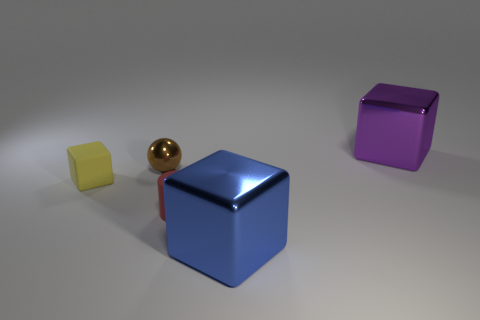Add 3 red objects. How many objects exist? 8 Subtract all cylinders. How many objects are left? 4 Subtract 1 brown balls. How many objects are left? 4 Subtract all red spheres. Subtract all red things. How many objects are left? 4 Add 5 large blue objects. How many large blue objects are left? 6 Add 3 tiny rubber cylinders. How many tiny rubber cylinders exist? 4 